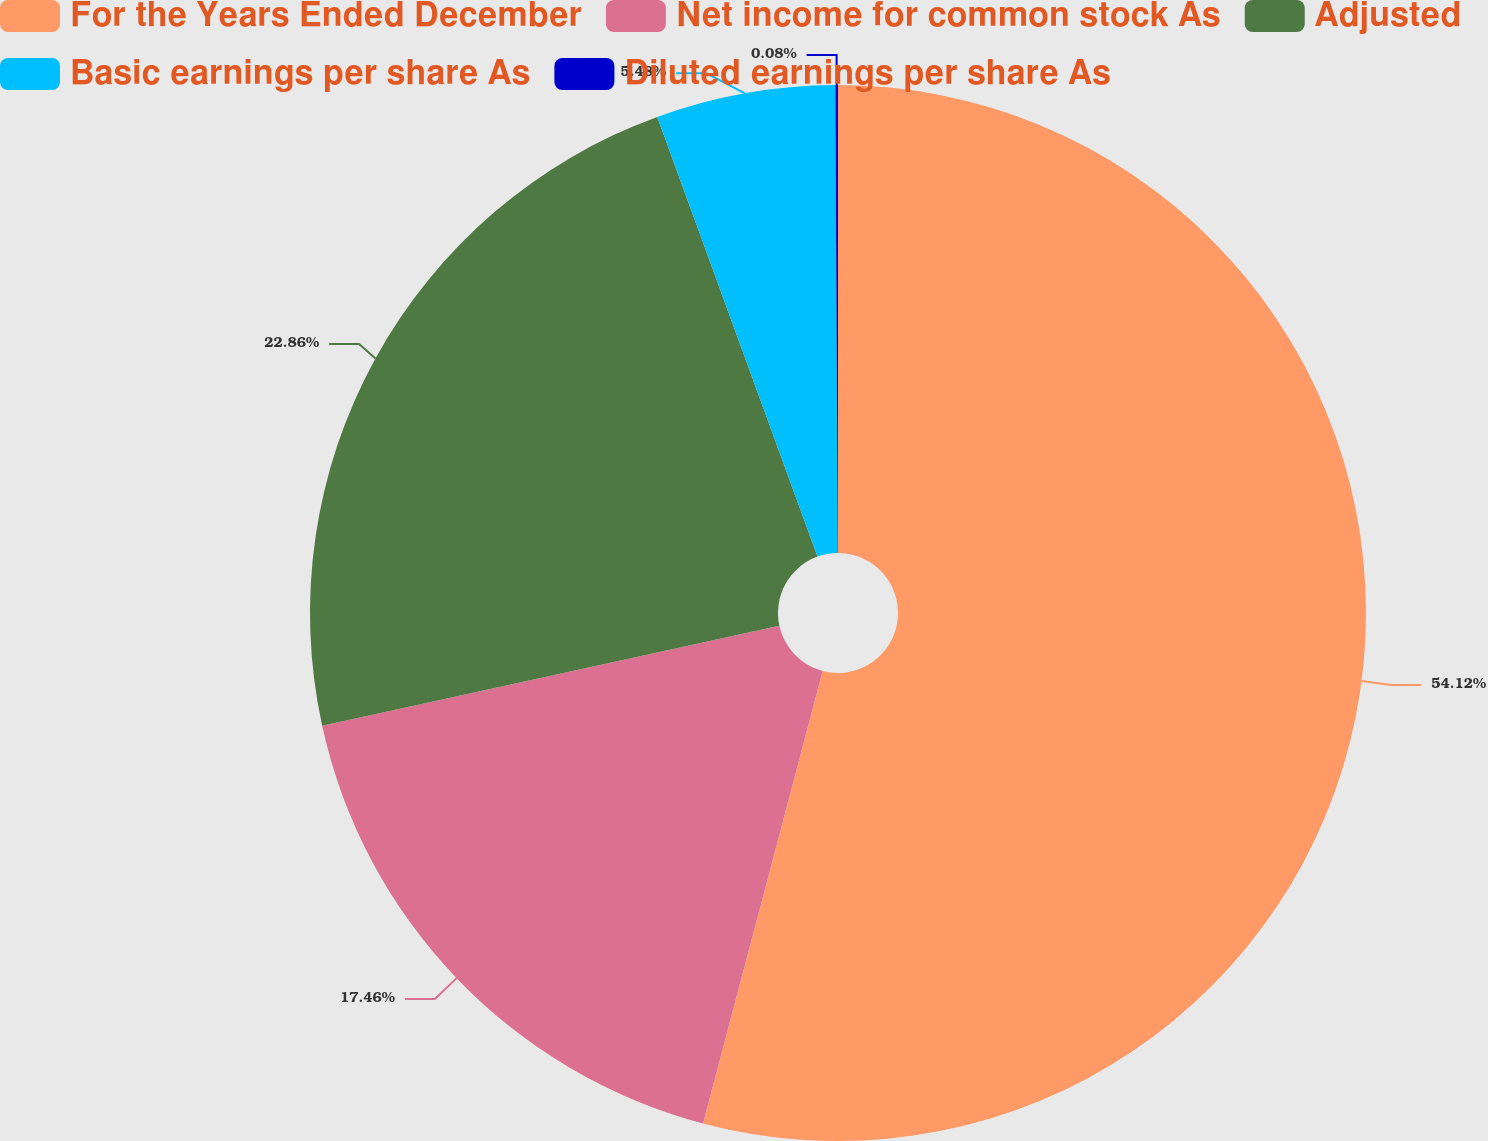Convert chart. <chart><loc_0><loc_0><loc_500><loc_500><pie_chart><fcel>For the Years Ended December<fcel>Net income for common stock As<fcel>Adjusted<fcel>Basic earnings per share As<fcel>Diluted earnings per share As<nl><fcel>54.11%<fcel>17.46%<fcel>22.86%<fcel>5.48%<fcel>0.08%<nl></chart> 